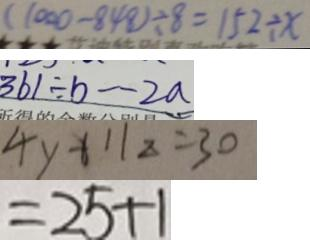<formula> <loc_0><loc_0><loc_500><loc_500>( 1 0 0 0 - 8 4 8 ) \div 8 = 1 5 2 \div x 
 3 6 1 \div b \cdot 2 a 
 4 y + 1 1 z = 3 0 
 = 2 5 + 1</formula> 